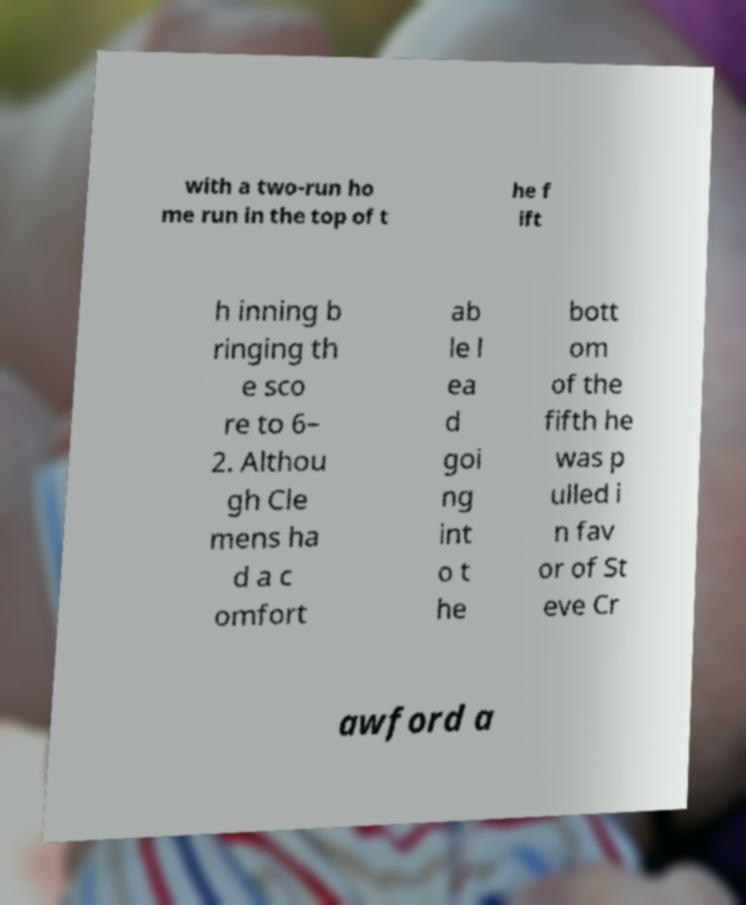Could you extract and type out the text from this image? with a two-run ho me run in the top of t he f ift h inning b ringing th e sco re to 6– 2. Althou gh Cle mens ha d a c omfort ab le l ea d goi ng int o t he bott om of the fifth he was p ulled i n fav or of St eve Cr awford a 